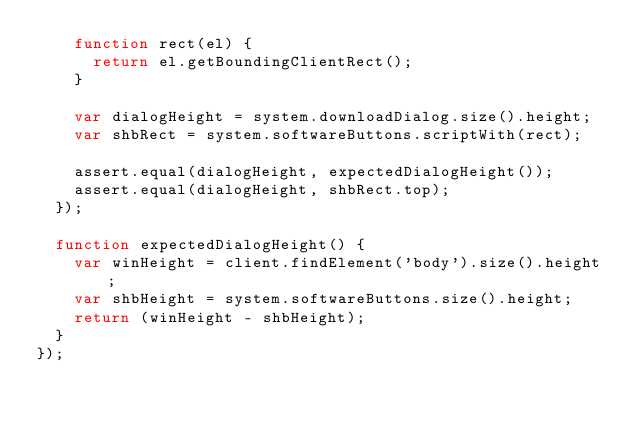<code> <loc_0><loc_0><loc_500><loc_500><_JavaScript_>    function rect(el) {
      return el.getBoundingClientRect();
    }

    var dialogHeight = system.downloadDialog.size().height;
    var shbRect = system.softwareButtons.scriptWith(rect);

    assert.equal(dialogHeight, expectedDialogHeight());
    assert.equal(dialogHeight, shbRect.top);
  });

  function expectedDialogHeight() {
    var winHeight = client.findElement('body').size().height;
    var shbHeight = system.softwareButtons.size().height;
    return (winHeight - shbHeight);
  }
});
</code> 